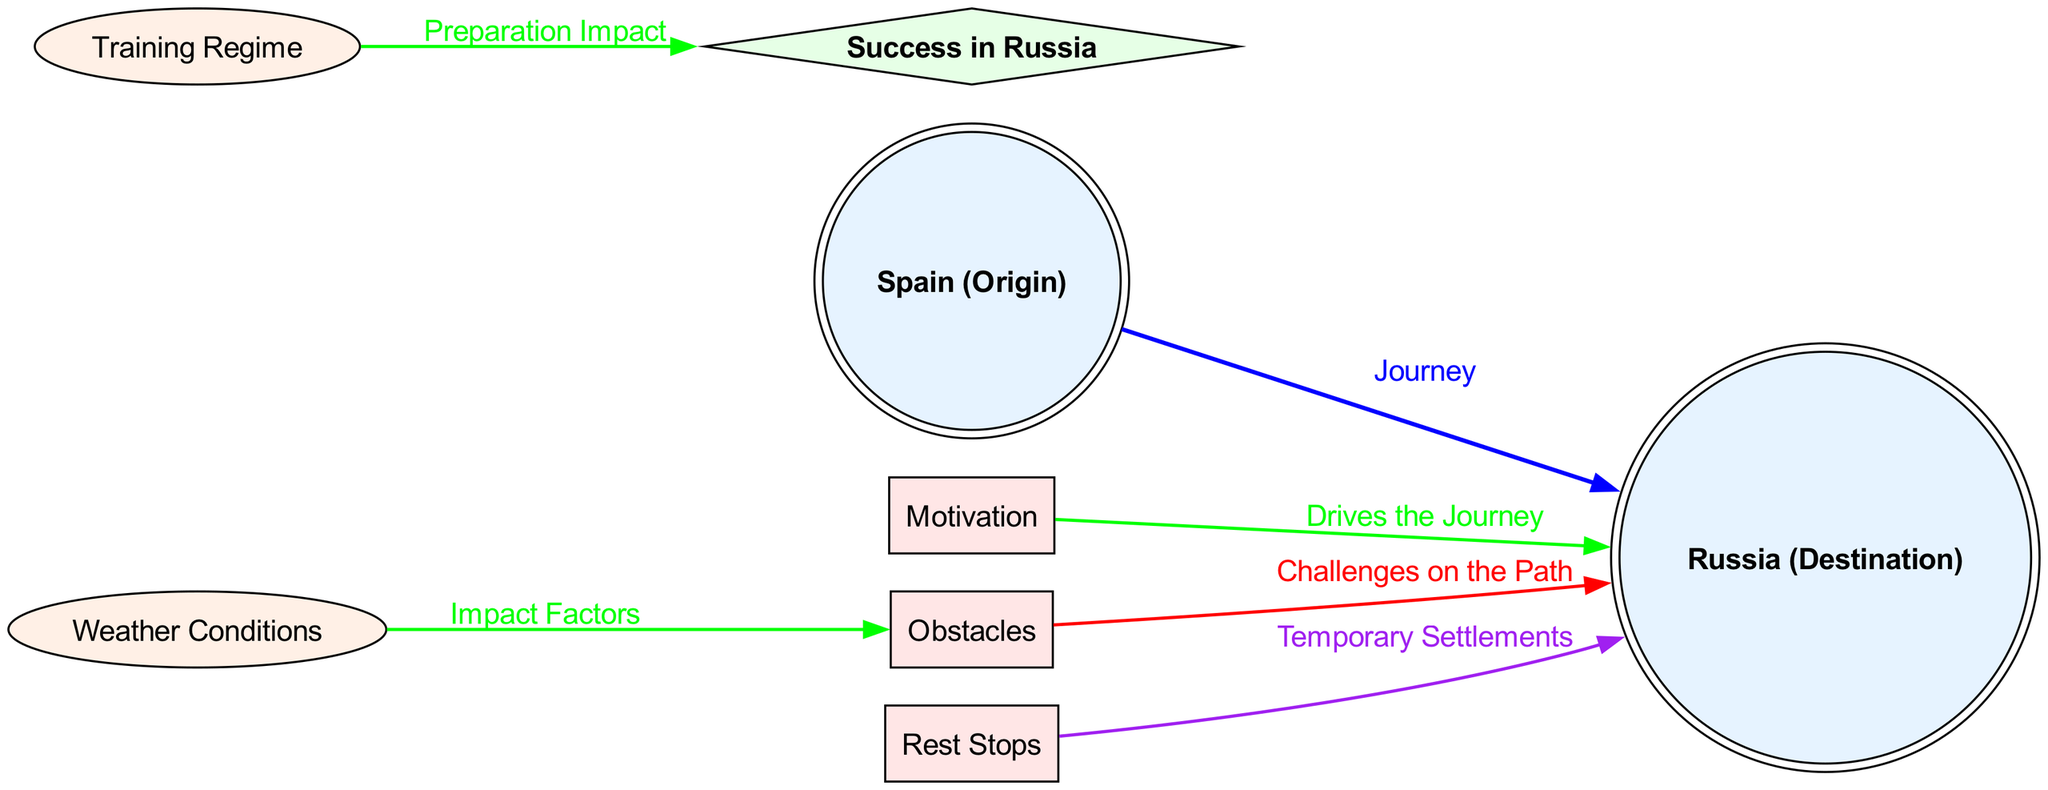What is the starting point of the migration? The diagram labels the node labeled "Spain (Origin)" as the starting point, representing the origin of the migration journey.
Answer: Spain (Origin) What is the destination of the migration? The node labeled "Russia (Destination)" signifies where the migration journey ends, identifying the destination of the storks or the football player.
Answer: Russia (Destination) How many factors influence the journey to Russia? The diagram shows three factors labeled "Motivation," "Obstacles," and "Rest Stops" that influence the migration journey. Counting these gives three.
Answer: 3 What type of relationship exists between weather conditions and obstacles? The diagram connects "Weather Conditions" to "Obstacles" with an "Impact Factors" label, indicating that weather influences obstacles during the journey.
Answer: Influence What does the "Training Regime" impact in the diagram? The connection from "Training Regime" to "Success" is marked with "Preparation Impact," illustrating that the training affects the likelihood of success in Russia.
Answer: Success How do "Rest Stops" relate to the journey towards Russia? The "Rest Stops" node connects to "Russia" labeled as "Temporary Settlements," indicating that rest stops facilitate the migration towards Russia.
Answer: Temporary Settlements What color represents the type of node for factors in the diagram? The diagram uses rectangles filled with a light red color (#FFE6E6) for factor nodes, visually distinguishing them from other types.
Answer: Light red What challenges are indicated along the path to Russia? The node "Obstacles" is labeled as "Challenges on the Path," highlighting the difficulties one may encounter while migrating to Russia.
Answer: Challenges on the Path What is the relationship between weather conditions and success? The diagram does not show a direct relationship from "Weather Conditions" to "Success," but indicates that weather influences obstacles which indirectly may affect success.
Answer: Indirectly influences How can the journey from Spain to Russia be described based on the diagram? The diagram illustrates a migration pattern that encompasses various influences like motivation, obstacles, and training, creating a comprehensive view of the journey to Russia.
Answer: Migration pattern 